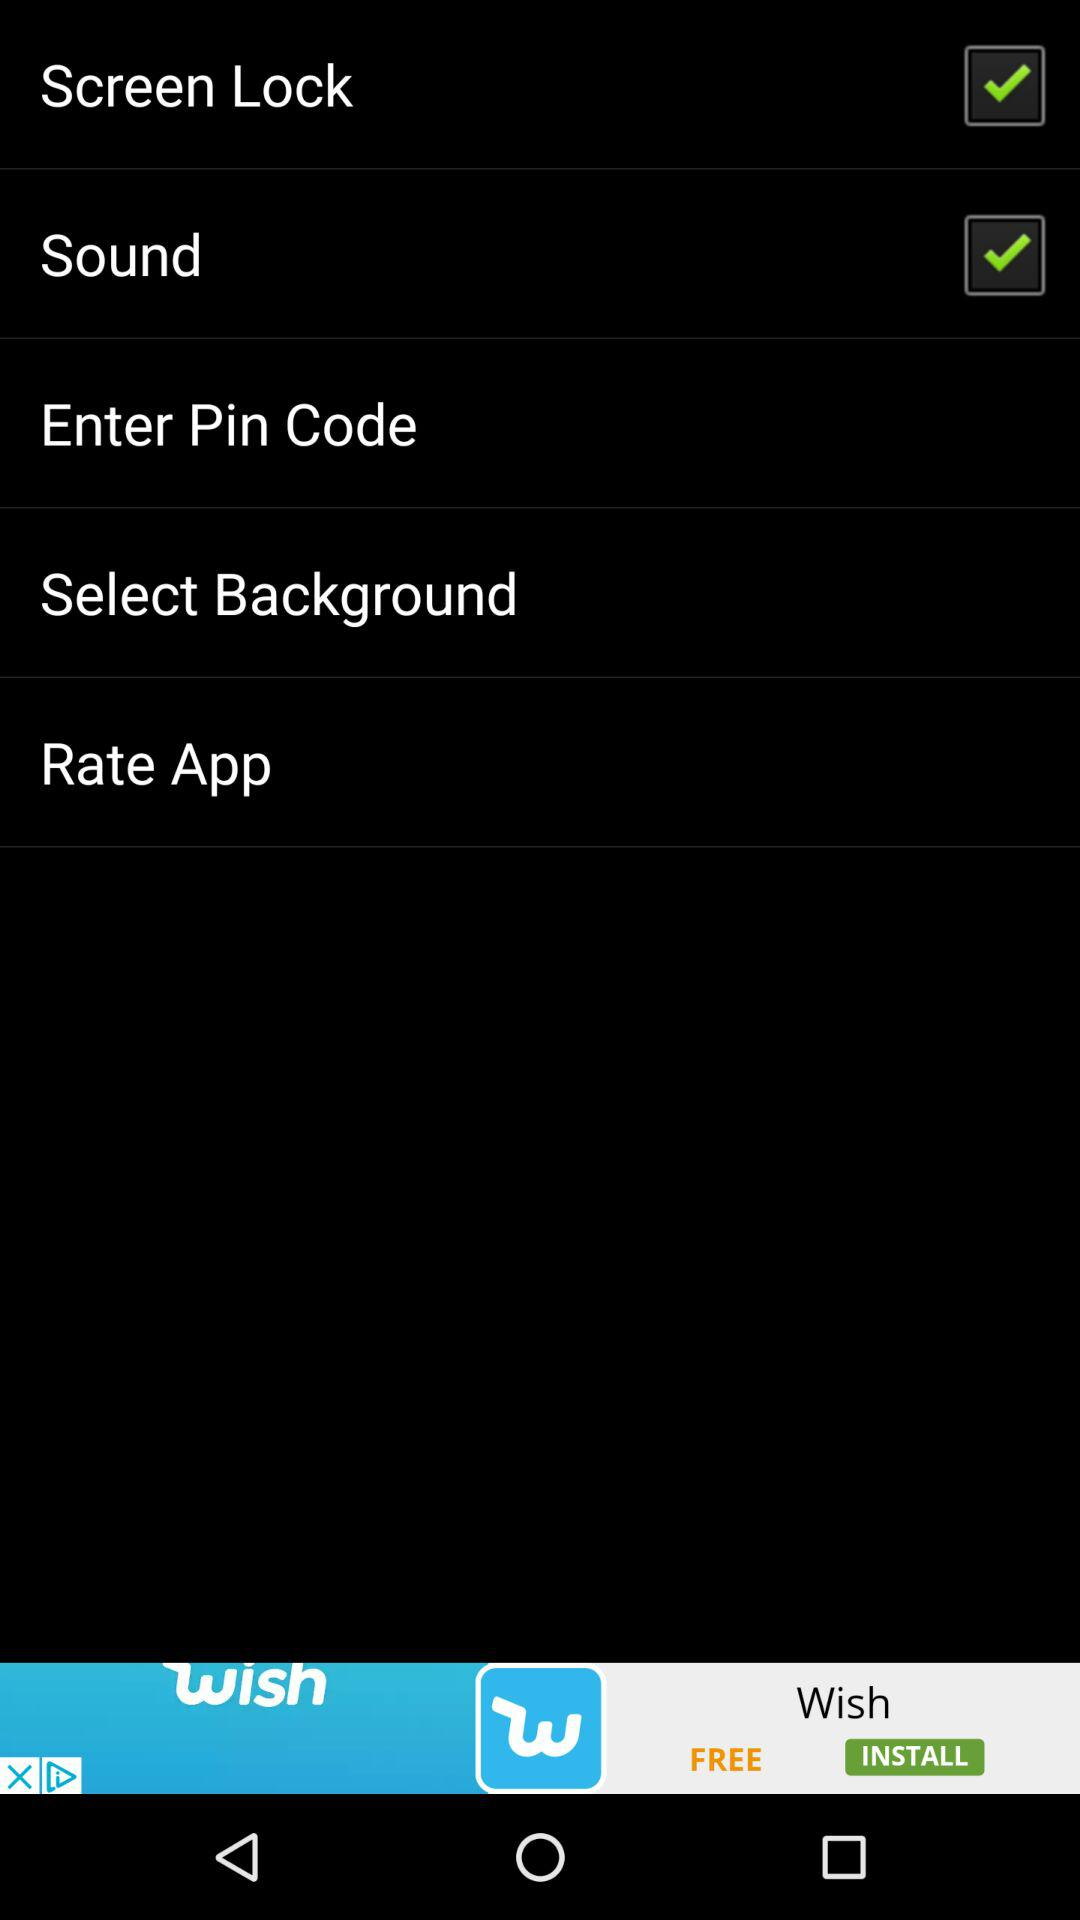What options are selected? The selected options are "Screen Lock" and "Sound". 